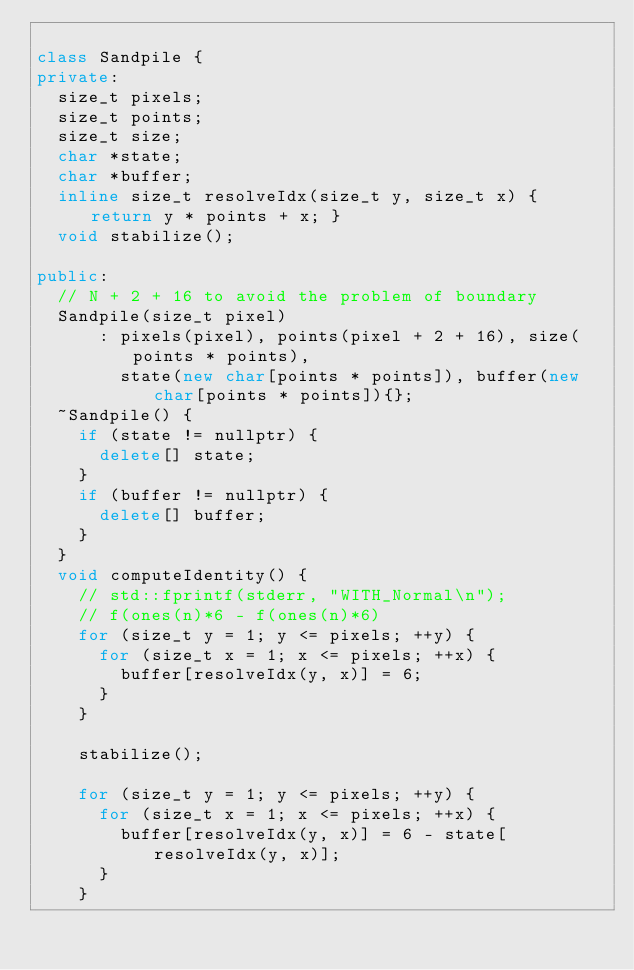<code> <loc_0><loc_0><loc_500><loc_500><_C++_>
class Sandpile {
private:
  size_t pixels;
  size_t points;
  size_t size;
  char *state;
  char *buffer;
  inline size_t resolveIdx(size_t y, size_t x) { return y * points + x; }
  void stabilize();

public:
  // N + 2 + 16 to avoid the problem of boundary
  Sandpile(size_t pixel)
      : pixels(pixel), points(pixel + 2 + 16), size(points * points),
        state(new char[points * points]), buffer(new char[points * points]){};
  ~Sandpile() {
    if (state != nullptr) {
      delete[] state;
    }
    if (buffer != nullptr) {
      delete[] buffer;
    }
  }
  void computeIdentity() {
    // std::fprintf(stderr, "WITH_Normal\n");
    // f(ones(n)*6 - f(ones(n)*6)
    for (size_t y = 1; y <= pixels; ++y) {
      for (size_t x = 1; x <= pixels; ++x) {
        buffer[resolveIdx(y, x)] = 6;
      }
    }

    stabilize();

    for (size_t y = 1; y <= pixels; ++y) {
      for (size_t x = 1; x <= pixels; ++x) {
        buffer[resolveIdx(y, x)] = 6 - state[resolveIdx(y, x)];
      }
    }
</code> 